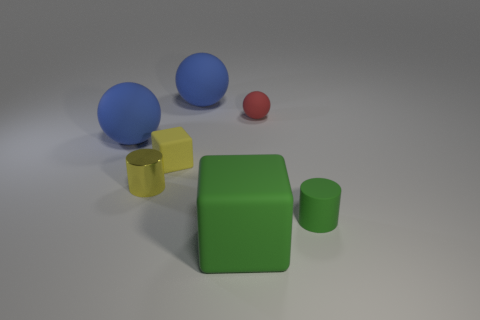Subtract all big balls. How many balls are left? 1 Add 3 large green cubes. How many objects exist? 10 Subtract all blue balls. How many balls are left? 1 Subtract 3 spheres. How many spheres are left? 0 Add 5 big green things. How many big green things exist? 6 Subtract 0 purple balls. How many objects are left? 7 Subtract all spheres. How many objects are left? 4 Subtract all yellow cylinders. Subtract all cyan cubes. How many cylinders are left? 1 Subtract all cyan balls. How many red blocks are left? 0 Subtract all big rubber cubes. Subtract all purple cubes. How many objects are left? 6 